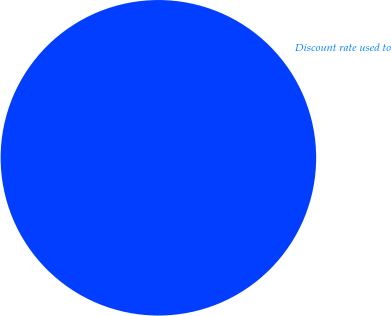Convert chart. <chart><loc_0><loc_0><loc_500><loc_500><pie_chart><fcel>Discount rate used to<nl><fcel>100.0%<nl></chart> 